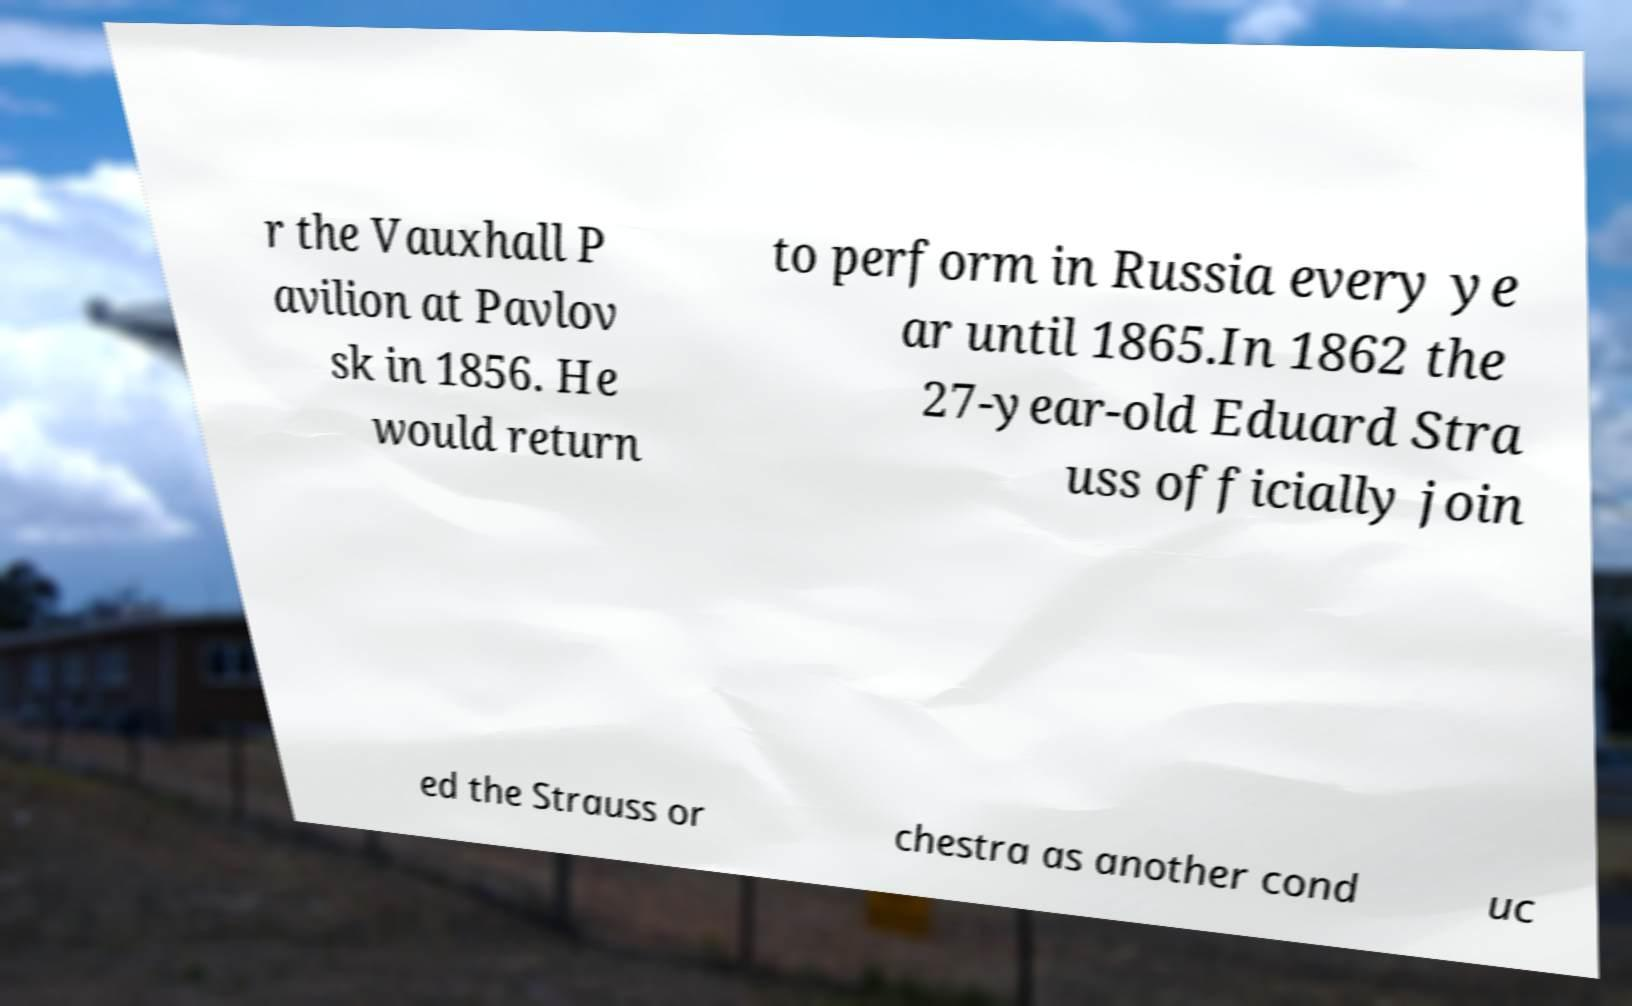Can you read and provide the text displayed in the image?This photo seems to have some interesting text. Can you extract and type it out for me? r the Vauxhall P avilion at Pavlov sk in 1856. He would return to perform in Russia every ye ar until 1865.In 1862 the 27-year-old Eduard Stra uss officially join ed the Strauss or chestra as another cond uc 